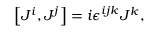<formula> <loc_0><loc_0><loc_500><loc_500>\left [ J ^ { i } , J ^ { j } \right ] = i \epsilon ^ { i j k } J ^ { k } ,</formula> 